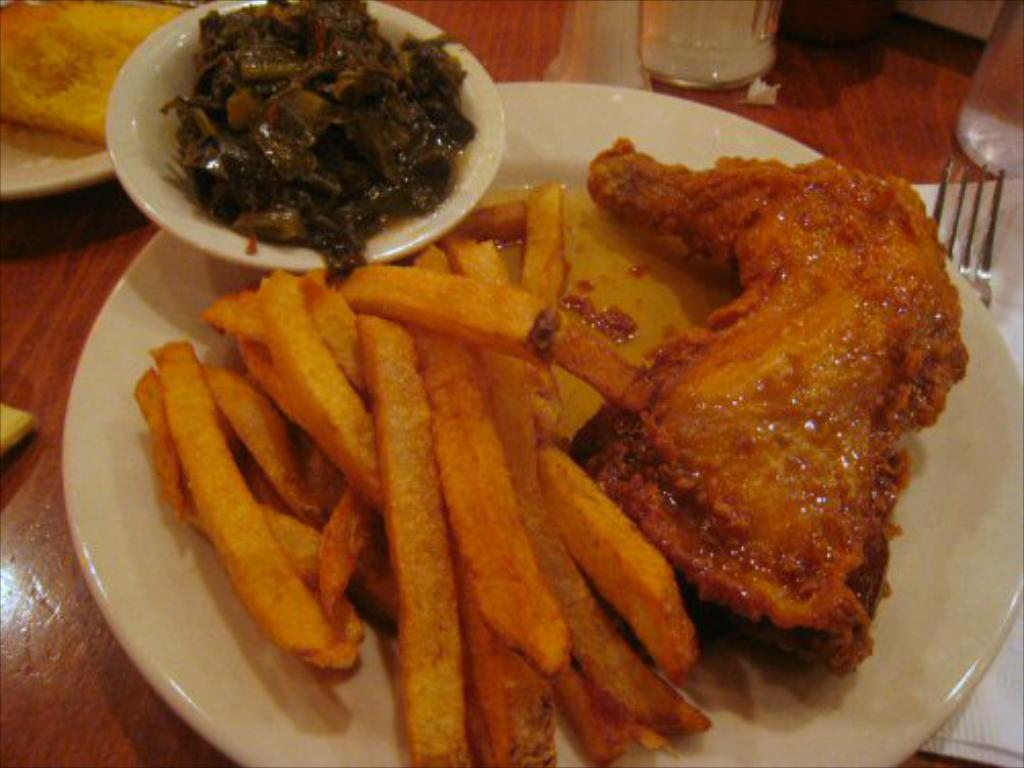What type of dishware can be seen in the image? There are plates in the image. What type of food is visible in the image? There are french fries in the image, which indicates that there is food present. What type of container is present in the image? There is a bowl in the image. What type of beverage container is present in the image? There is a glass in the image. Where are these objects located in the image? The objects are on a wooden surface in the image. What historical event is being commemorated by the french fries in the image? The french fries in the image are not commemorating any historical event; they are simply a type of food. 